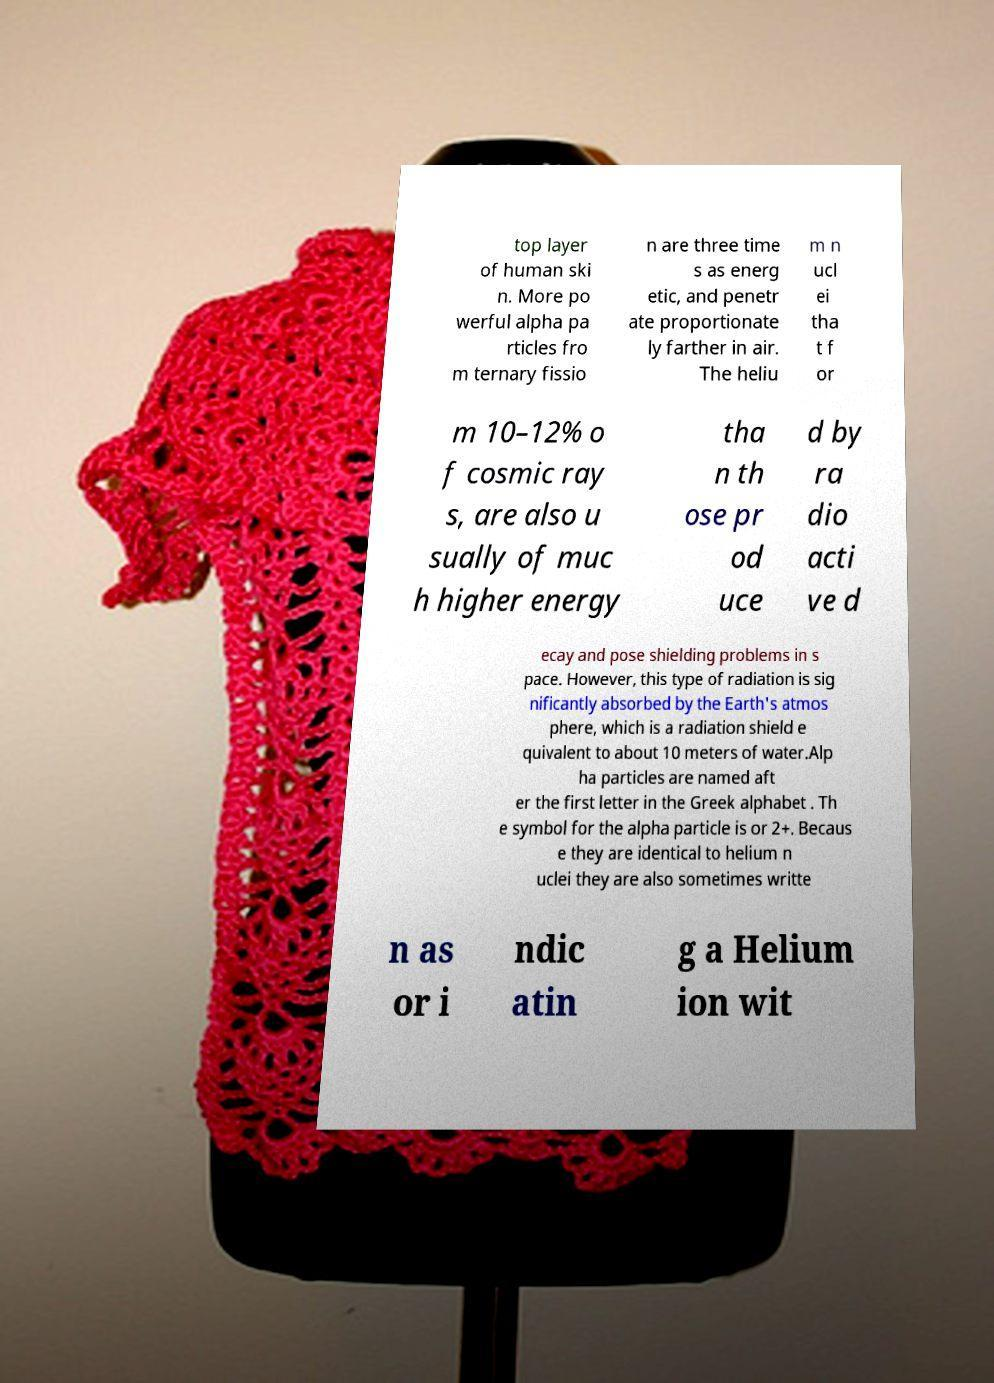Please read and relay the text visible in this image. What does it say? top layer of human ski n. More po werful alpha pa rticles fro m ternary fissio n are three time s as energ etic, and penetr ate proportionate ly farther in air. The heliu m n ucl ei tha t f or m 10–12% o f cosmic ray s, are also u sually of muc h higher energy tha n th ose pr od uce d by ra dio acti ve d ecay and pose shielding problems in s pace. However, this type of radiation is sig nificantly absorbed by the Earth's atmos phere, which is a radiation shield e quivalent to about 10 meters of water.Alp ha particles are named aft er the first letter in the Greek alphabet . Th e symbol for the alpha particle is or 2+. Becaus e they are identical to helium n uclei they are also sometimes writte n as or i ndic atin g a Helium ion wit 